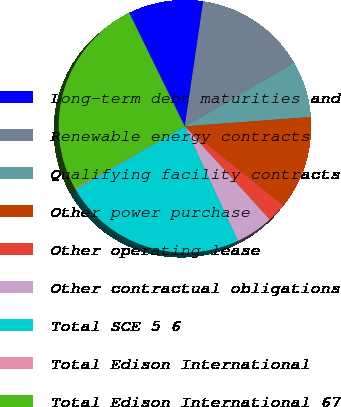<chart> <loc_0><loc_0><loc_500><loc_500><pie_chart><fcel>Long-term debt maturities and<fcel>Renewable energy contracts<fcel>Qualifying facility contracts<fcel>Other power purchase<fcel>Other operating lease<fcel>Other contractual obligations<fcel>Total SCE 5 6<fcel>Total Edison International<fcel>Total Edison International 67<nl><fcel>9.57%<fcel>14.29%<fcel>7.21%<fcel>11.93%<fcel>2.49%<fcel>4.85%<fcel>23.6%<fcel>0.13%<fcel>25.96%<nl></chart> 